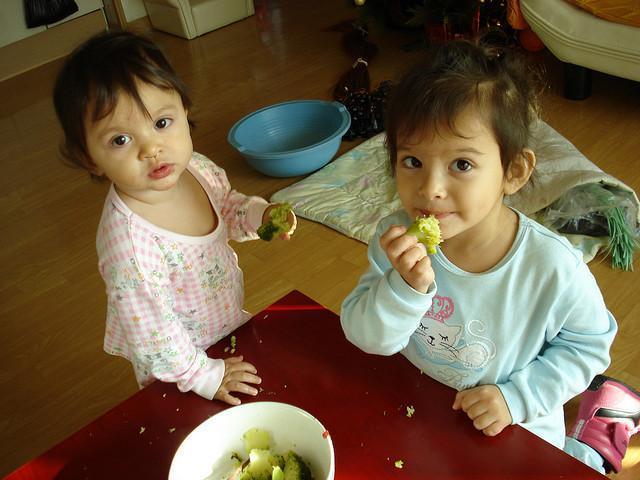How many people can be seen?
Give a very brief answer. 2. How many bowls are there?
Give a very brief answer. 2. 